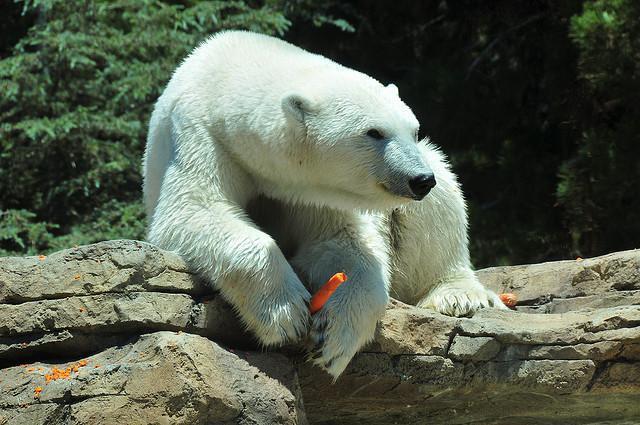How many bears are there?
Give a very brief answer. 1. How many people in the picture are wearing glasses?
Give a very brief answer. 0. 